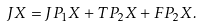Convert formula to latex. <formula><loc_0><loc_0><loc_500><loc_500>J X = J P _ { 1 } X + T P _ { 2 } X + F P _ { 2 } X .</formula> 